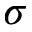Convert formula to latex. <formula><loc_0><loc_0><loc_500><loc_500>\sigma</formula> 